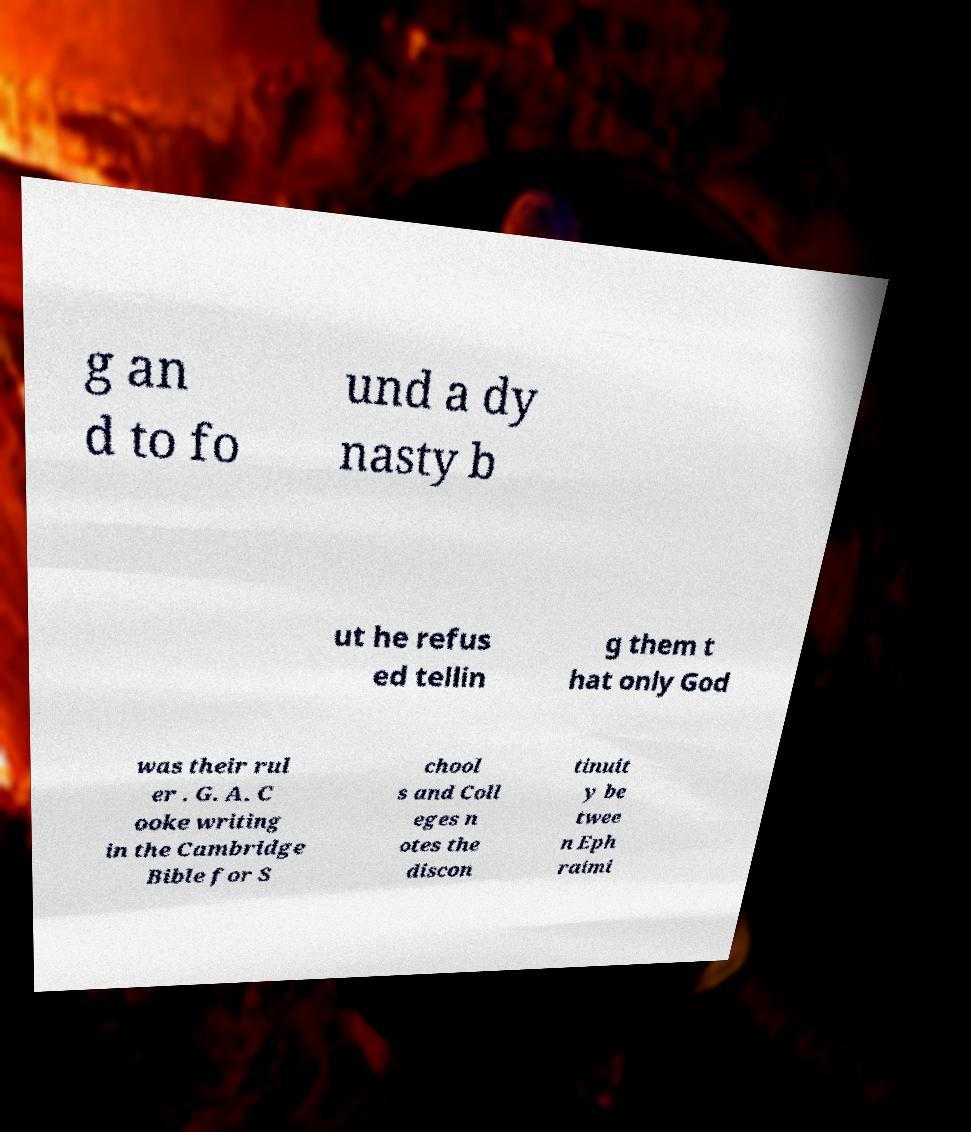For documentation purposes, I need the text within this image transcribed. Could you provide that? g an d to fo und a dy nasty b ut he refus ed tellin g them t hat only God was their rul er . G. A. C ooke writing in the Cambridge Bible for S chool s and Coll eges n otes the discon tinuit y be twee n Eph raimi 